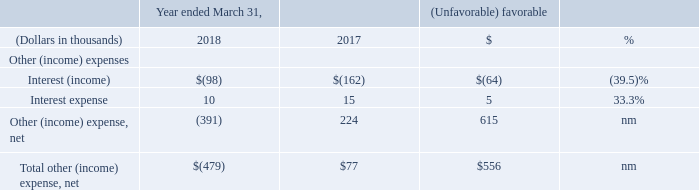Other (Income) Expenses
nm - not meaningful
Interest income. Interest income decreased $64,000 during fiscal 2018 as compared to fiscal 2017.
Interest expense. Interest expense consists of costs associated with capital leases and loans on corporate-owned life insurance policies.
Other (income) expense, net. Other (income) expense, net consists mainly of the impact of foreign currency due to movement of European and Asian currencies against the US dollar.
What was the decrease in interest income in fiscal 2018? $64,000. What are the interest expense comprised of? Costs associated with capital leases and loans on corporate-owned life insurance policies. What is the interest income in 2018?
Answer scale should be: thousand. $(98). What is  Interest (income) expressed as a percentage of  Total other (income) expense, net?
Answer scale should be: percent. -98/-479
Answer: 20.46. What is the average interest expense for 2017 and 2018?
Answer scale should be: thousand. (10 + 15) / 2
Answer: 12.5. What is the average Other (income) expense, net for 2017 and 2018?
Answer scale should be: thousand. (-391 + 224) / 2
Answer: -83.5. 